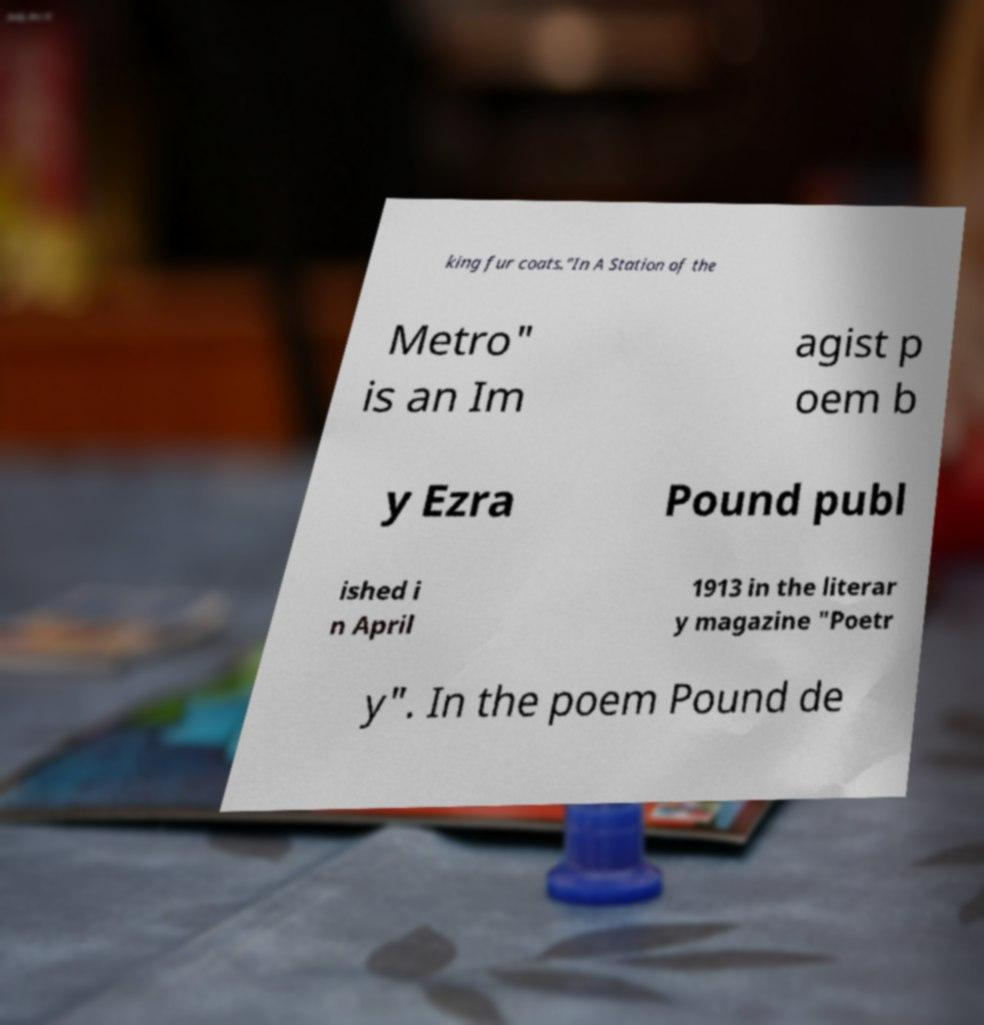There's text embedded in this image that I need extracted. Can you transcribe it verbatim? king fur coats."In A Station of the Metro" is an Im agist p oem b y Ezra Pound publ ished i n April 1913 in the literar y magazine "Poetr y". In the poem Pound de 